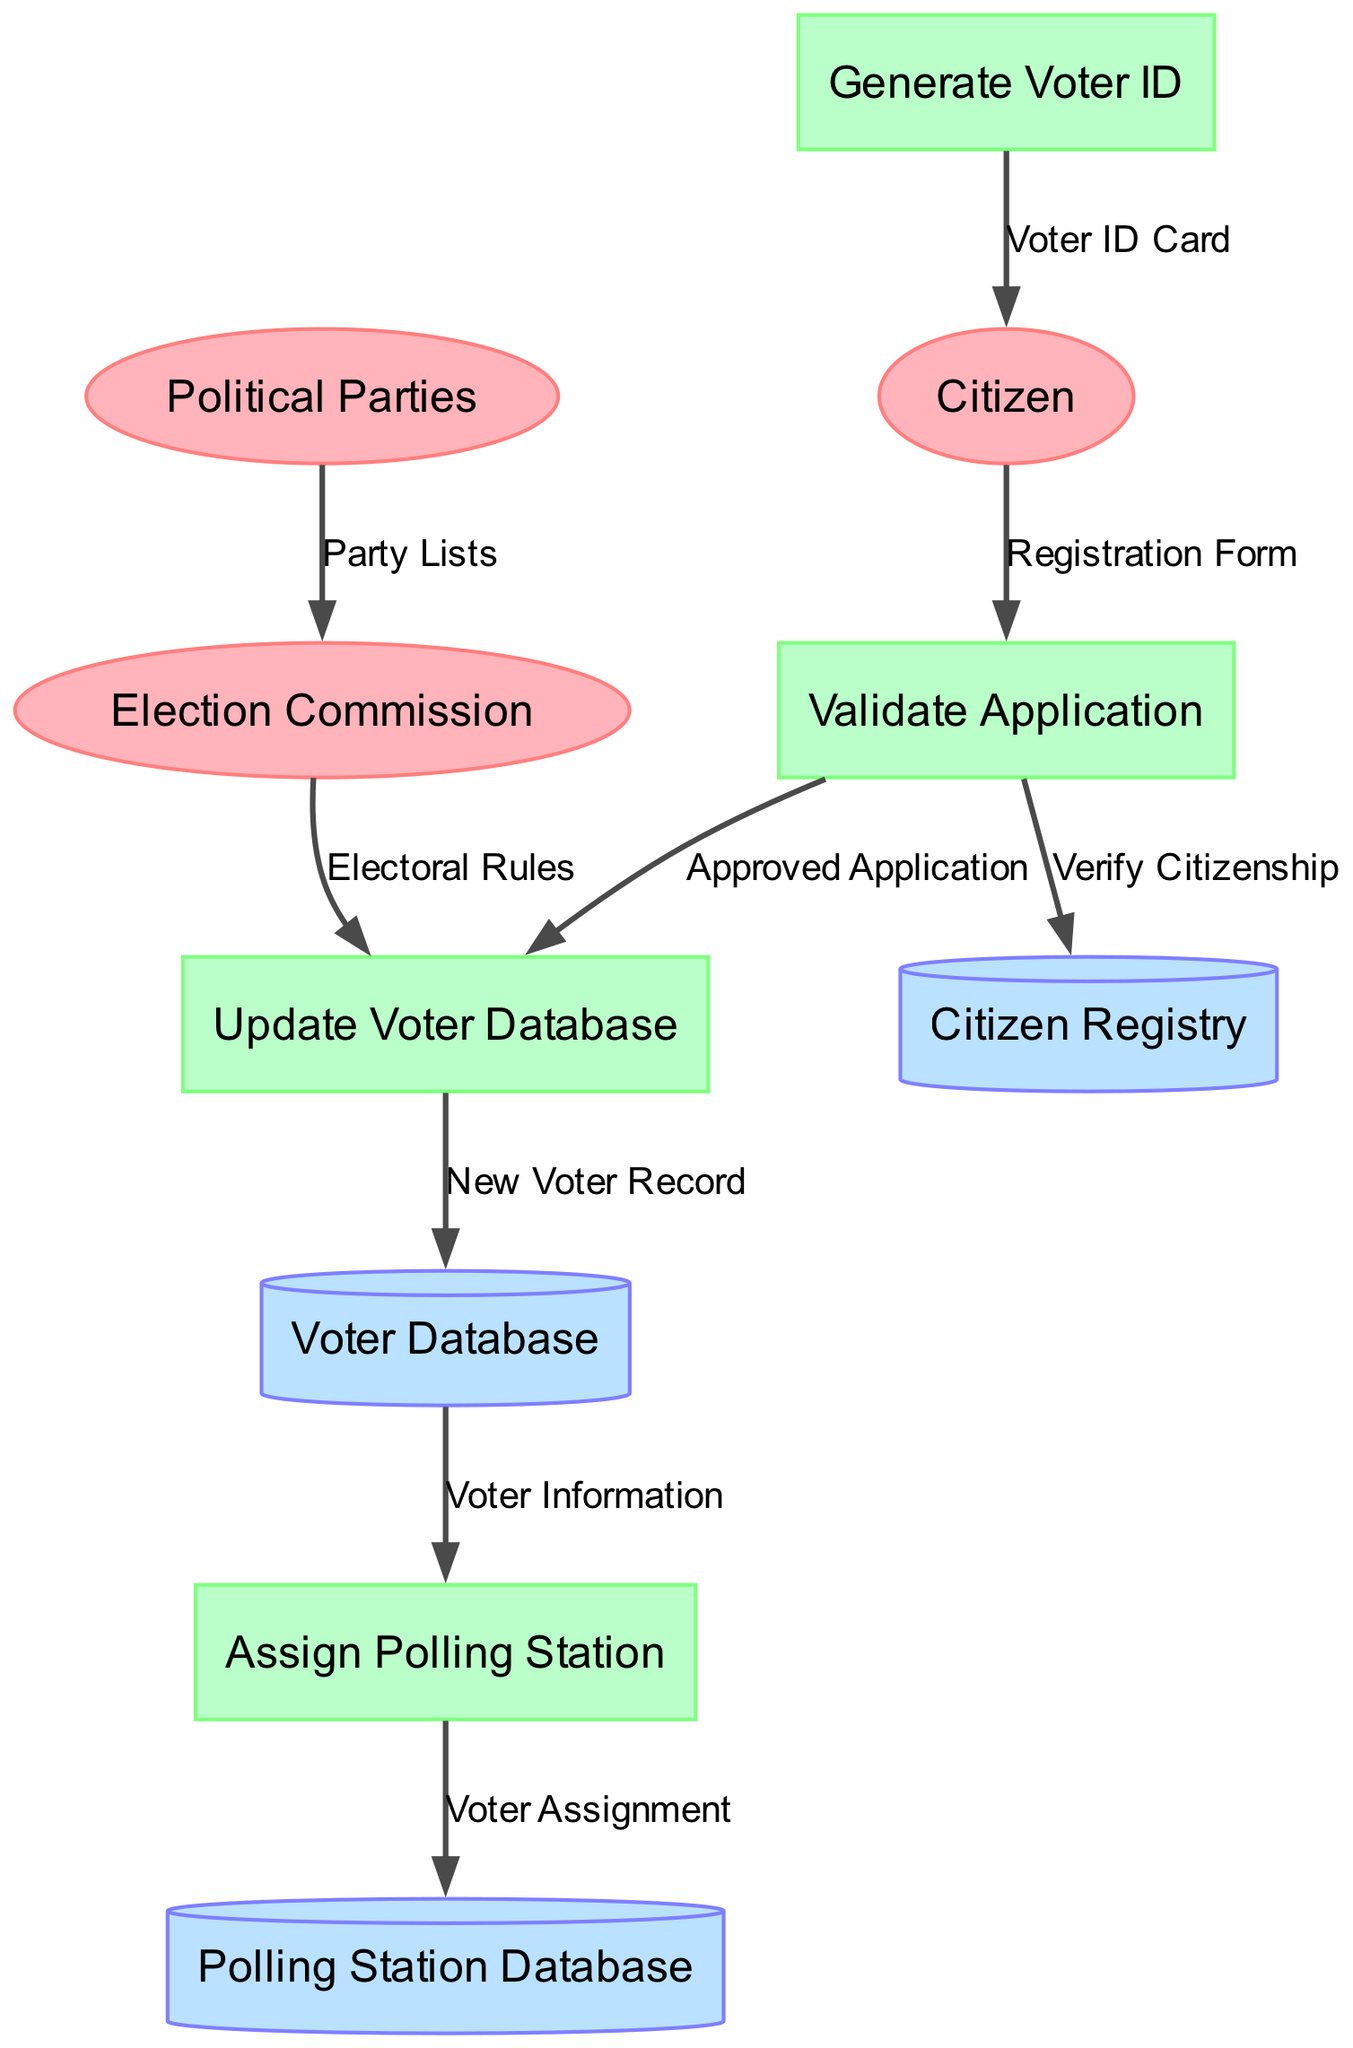What is the first step in the electoral registration process? The first step shown in the diagram is "Validate Application," where the citizen's registration form is submitted and processed for validation.
Answer: Validate Application How many external entities are present in the diagram? The diagram lists three external entities: Citizen, Election Commission, and Political Parties. Therefore, the total number of external entities is counted as three.
Answer: 3 What data store receives "Verified Citizenship" from the "Validate Application" process? According to the flows outlined in the diagram, the "Validate Application" process sends "Verify Citizenship" to the "Citizen Registry" data store for verification purposes.
Answer: Citizen Registry Which process generates the "Voter ID Card"? The "Generate Voter ID" process is responsible for creating and issuing the "Voter ID Card" to the citizen after their application is approved.
Answer: Generate Voter ID What does the "Election Commission" send to the "Update Voter Database" process? The "Election Commission" provides "Electoral Rules" that guide the updating of the voter database to reflect new regulations.
Answer: Electoral Rules What is the final step in the registration process concerning the polling station? The last step in the voter registration process related to polling stations is "Assign Polling Station," which assigns voters to their respective polling locations.
Answer: Assign Polling Station Which data flow represents the relationship between the "Voter Database" and "Assign Polling Station"? The flow between these two processes is labeled "Voter Information," indicating that information from the voter database is utilized to assign polling stations to voters.
Answer: Voter Information How does a citizen receive their voter identification after the application process? After completing the appropriate processes including validation and approval, the citizen receives their voter identification through the "Generate Voter ID" process, which outputs the "Voter ID Card" to them.
Answer: Voter ID Card What is the purpose of the "Polling Station Database"? The "Polling Station Database" is utilized to store all assignments made during the "Assign Polling Station" process, ensuring efficient management of polling locations for the electoral system.
Answer: Assignment storage 